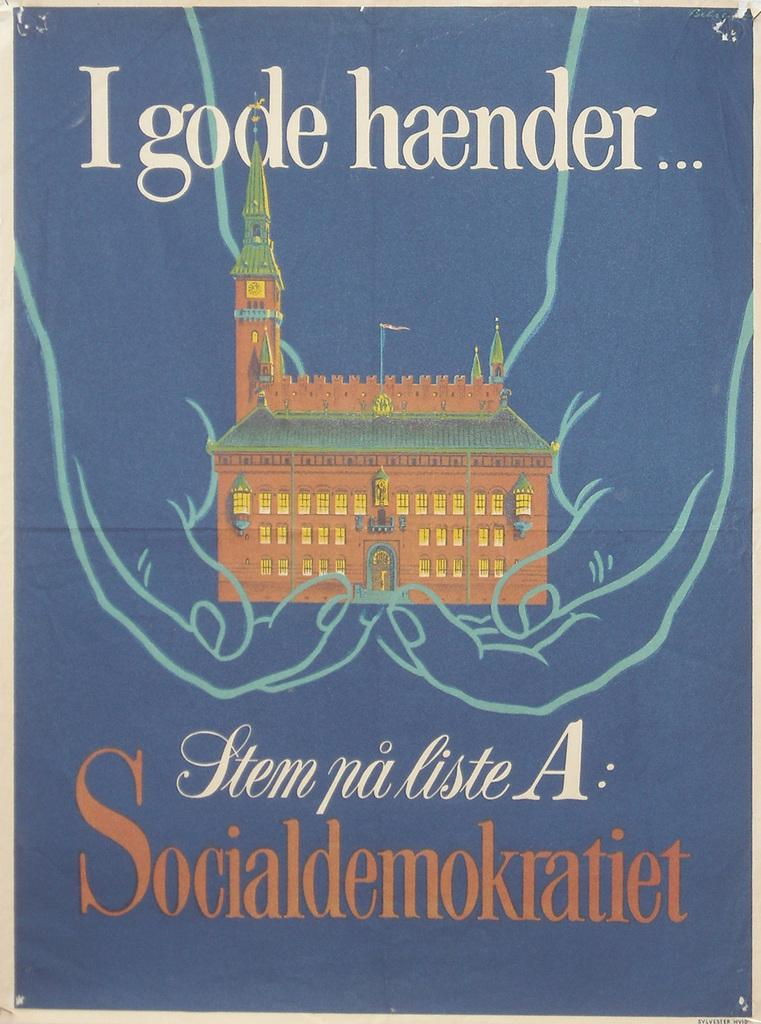<image>
Describe the image concisely. Vintage poster in periwinkle blue background Igode haender in a foreign language with a schloss (school) builiding 